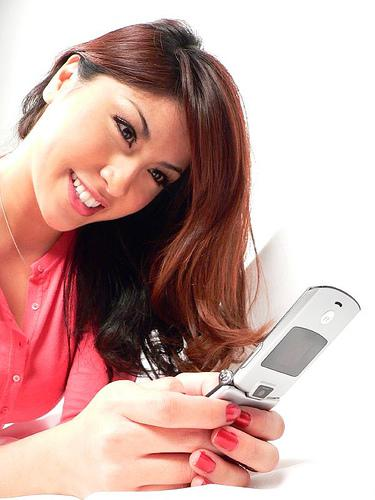Question: what is the woman doing?
Choices:
A. Looking out the window.
B. Looking at her cell phone.
C. Looking at the television.
D. Looking at the computer.
Answer with the letter. Answer: B Question: when is the woman looking at her cell phone?
Choices:
A. Earlier in the day.
B. Now.
C. At night.
D. When she leaves her house.
Answer with the letter. Answer: B Question: who is looking at the cell phone?
Choices:
A. A man.
B. A woman.
C. A little girl.
D. A teenage boy.
Answer with the letter. Answer: B Question: what color is the woman's shirt?
Choices:
A. Pink.
B. Blue.
C. Black.
D. Red.
Answer with the letter. Answer: A 